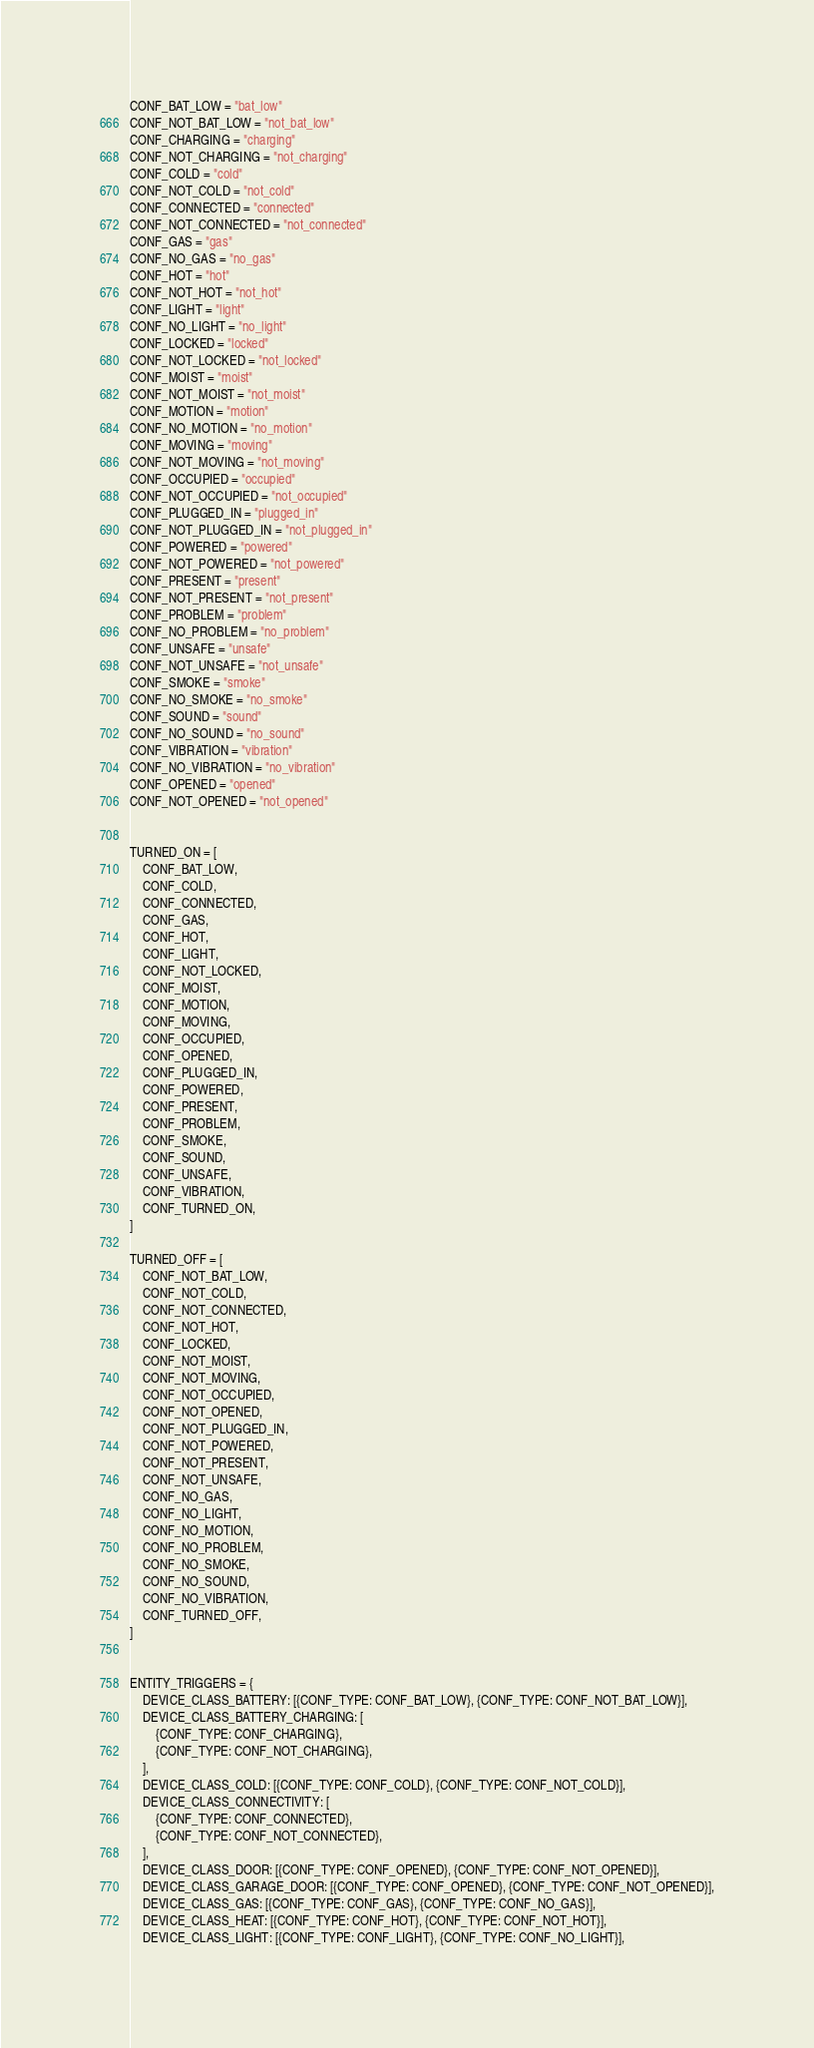Convert code to text. <code><loc_0><loc_0><loc_500><loc_500><_Python_>CONF_BAT_LOW = "bat_low"
CONF_NOT_BAT_LOW = "not_bat_low"
CONF_CHARGING = "charging"
CONF_NOT_CHARGING = "not_charging"
CONF_COLD = "cold"
CONF_NOT_COLD = "not_cold"
CONF_CONNECTED = "connected"
CONF_NOT_CONNECTED = "not_connected"
CONF_GAS = "gas"
CONF_NO_GAS = "no_gas"
CONF_HOT = "hot"
CONF_NOT_HOT = "not_hot"
CONF_LIGHT = "light"
CONF_NO_LIGHT = "no_light"
CONF_LOCKED = "locked"
CONF_NOT_LOCKED = "not_locked"
CONF_MOIST = "moist"
CONF_NOT_MOIST = "not_moist"
CONF_MOTION = "motion"
CONF_NO_MOTION = "no_motion"
CONF_MOVING = "moving"
CONF_NOT_MOVING = "not_moving"
CONF_OCCUPIED = "occupied"
CONF_NOT_OCCUPIED = "not_occupied"
CONF_PLUGGED_IN = "plugged_in"
CONF_NOT_PLUGGED_IN = "not_plugged_in"
CONF_POWERED = "powered"
CONF_NOT_POWERED = "not_powered"
CONF_PRESENT = "present"
CONF_NOT_PRESENT = "not_present"
CONF_PROBLEM = "problem"
CONF_NO_PROBLEM = "no_problem"
CONF_UNSAFE = "unsafe"
CONF_NOT_UNSAFE = "not_unsafe"
CONF_SMOKE = "smoke"
CONF_NO_SMOKE = "no_smoke"
CONF_SOUND = "sound"
CONF_NO_SOUND = "no_sound"
CONF_VIBRATION = "vibration"
CONF_NO_VIBRATION = "no_vibration"
CONF_OPENED = "opened"
CONF_NOT_OPENED = "not_opened"


TURNED_ON = [
    CONF_BAT_LOW,
    CONF_COLD,
    CONF_CONNECTED,
    CONF_GAS,
    CONF_HOT,
    CONF_LIGHT,
    CONF_NOT_LOCKED,
    CONF_MOIST,
    CONF_MOTION,
    CONF_MOVING,
    CONF_OCCUPIED,
    CONF_OPENED,
    CONF_PLUGGED_IN,
    CONF_POWERED,
    CONF_PRESENT,
    CONF_PROBLEM,
    CONF_SMOKE,
    CONF_SOUND,
    CONF_UNSAFE,
    CONF_VIBRATION,
    CONF_TURNED_ON,
]

TURNED_OFF = [
    CONF_NOT_BAT_LOW,
    CONF_NOT_COLD,
    CONF_NOT_CONNECTED,
    CONF_NOT_HOT,
    CONF_LOCKED,
    CONF_NOT_MOIST,
    CONF_NOT_MOVING,
    CONF_NOT_OCCUPIED,
    CONF_NOT_OPENED,
    CONF_NOT_PLUGGED_IN,
    CONF_NOT_POWERED,
    CONF_NOT_PRESENT,
    CONF_NOT_UNSAFE,
    CONF_NO_GAS,
    CONF_NO_LIGHT,
    CONF_NO_MOTION,
    CONF_NO_PROBLEM,
    CONF_NO_SMOKE,
    CONF_NO_SOUND,
    CONF_NO_VIBRATION,
    CONF_TURNED_OFF,
]


ENTITY_TRIGGERS = {
    DEVICE_CLASS_BATTERY: [{CONF_TYPE: CONF_BAT_LOW}, {CONF_TYPE: CONF_NOT_BAT_LOW}],
    DEVICE_CLASS_BATTERY_CHARGING: [
        {CONF_TYPE: CONF_CHARGING},
        {CONF_TYPE: CONF_NOT_CHARGING},
    ],
    DEVICE_CLASS_COLD: [{CONF_TYPE: CONF_COLD}, {CONF_TYPE: CONF_NOT_COLD}],
    DEVICE_CLASS_CONNECTIVITY: [
        {CONF_TYPE: CONF_CONNECTED},
        {CONF_TYPE: CONF_NOT_CONNECTED},
    ],
    DEVICE_CLASS_DOOR: [{CONF_TYPE: CONF_OPENED}, {CONF_TYPE: CONF_NOT_OPENED}],
    DEVICE_CLASS_GARAGE_DOOR: [{CONF_TYPE: CONF_OPENED}, {CONF_TYPE: CONF_NOT_OPENED}],
    DEVICE_CLASS_GAS: [{CONF_TYPE: CONF_GAS}, {CONF_TYPE: CONF_NO_GAS}],
    DEVICE_CLASS_HEAT: [{CONF_TYPE: CONF_HOT}, {CONF_TYPE: CONF_NOT_HOT}],
    DEVICE_CLASS_LIGHT: [{CONF_TYPE: CONF_LIGHT}, {CONF_TYPE: CONF_NO_LIGHT}],</code> 